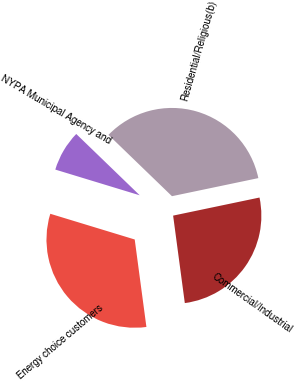<chart> <loc_0><loc_0><loc_500><loc_500><pie_chart><fcel>Residential/Religious(b)<fcel>Commercial/Industrial<fcel>Energy choice customers<fcel>NYPA Municipal Agency and<nl><fcel>34.49%<fcel>26.17%<fcel>31.82%<fcel>7.52%<nl></chart> 